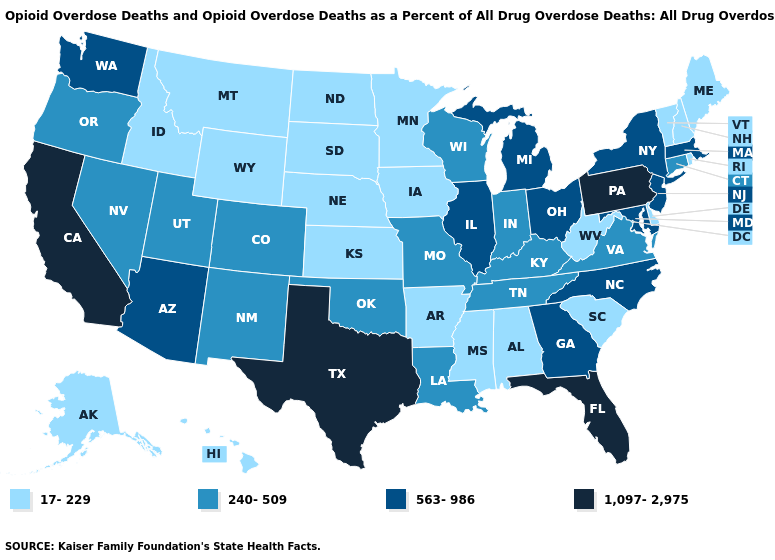Name the states that have a value in the range 17-229?
Short answer required. Alabama, Alaska, Arkansas, Delaware, Hawaii, Idaho, Iowa, Kansas, Maine, Minnesota, Mississippi, Montana, Nebraska, New Hampshire, North Dakota, Rhode Island, South Carolina, South Dakota, Vermont, West Virginia, Wyoming. Among the states that border Illinois , which have the lowest value?
Be succinct. Iowa. Which states hav the highest value in the MidWest?
Quick response, please. Illinois, Michigan, Ohio. Name the states that have a value in the range 563-986?
Write a very short answer. Arizona, Georgia, Illinois, Maryland, Massachusetts, Michigan, New Jersey, New York, North Carolina, Ohio, Washington. What is the highest value in the USA?
Keep it brief. 1,097-2,975. Does Kansas have a lower value than New York?
Quick response, please. Yes. Does California have the highest value in the West?
Concise answer only. Yes. Does Pennsylvania have the highest value in the USA?
Answer briefly. Yes. Does Connecticut have the lowest value in the Northeast?
Answer briefly. No. What is the value of Connecticut?
Answer briefly. 240-509. What is the value of Connecticut?
Be succinct. 240-509. Does the map have missing data?
Quick response, please. No. Name the states that have a value in the range 17-229?
Short answer required. Alabama, Alaska, Arkansas, Delaware, Hawaii, Idaho, Iowa, Kansas, Maine, Minnesota, Mississippi, Montana, Nebraska, New Hampshire, North Dakota, Rhode Island, South Carolina, South Dakota, Vermont, West Virginia, Wyoming. Among the states that border Maryland , does Delaware have the highest value?
Write a very short answer. No. Does New York have a lower value than California?
Answer briefly. Yes. 